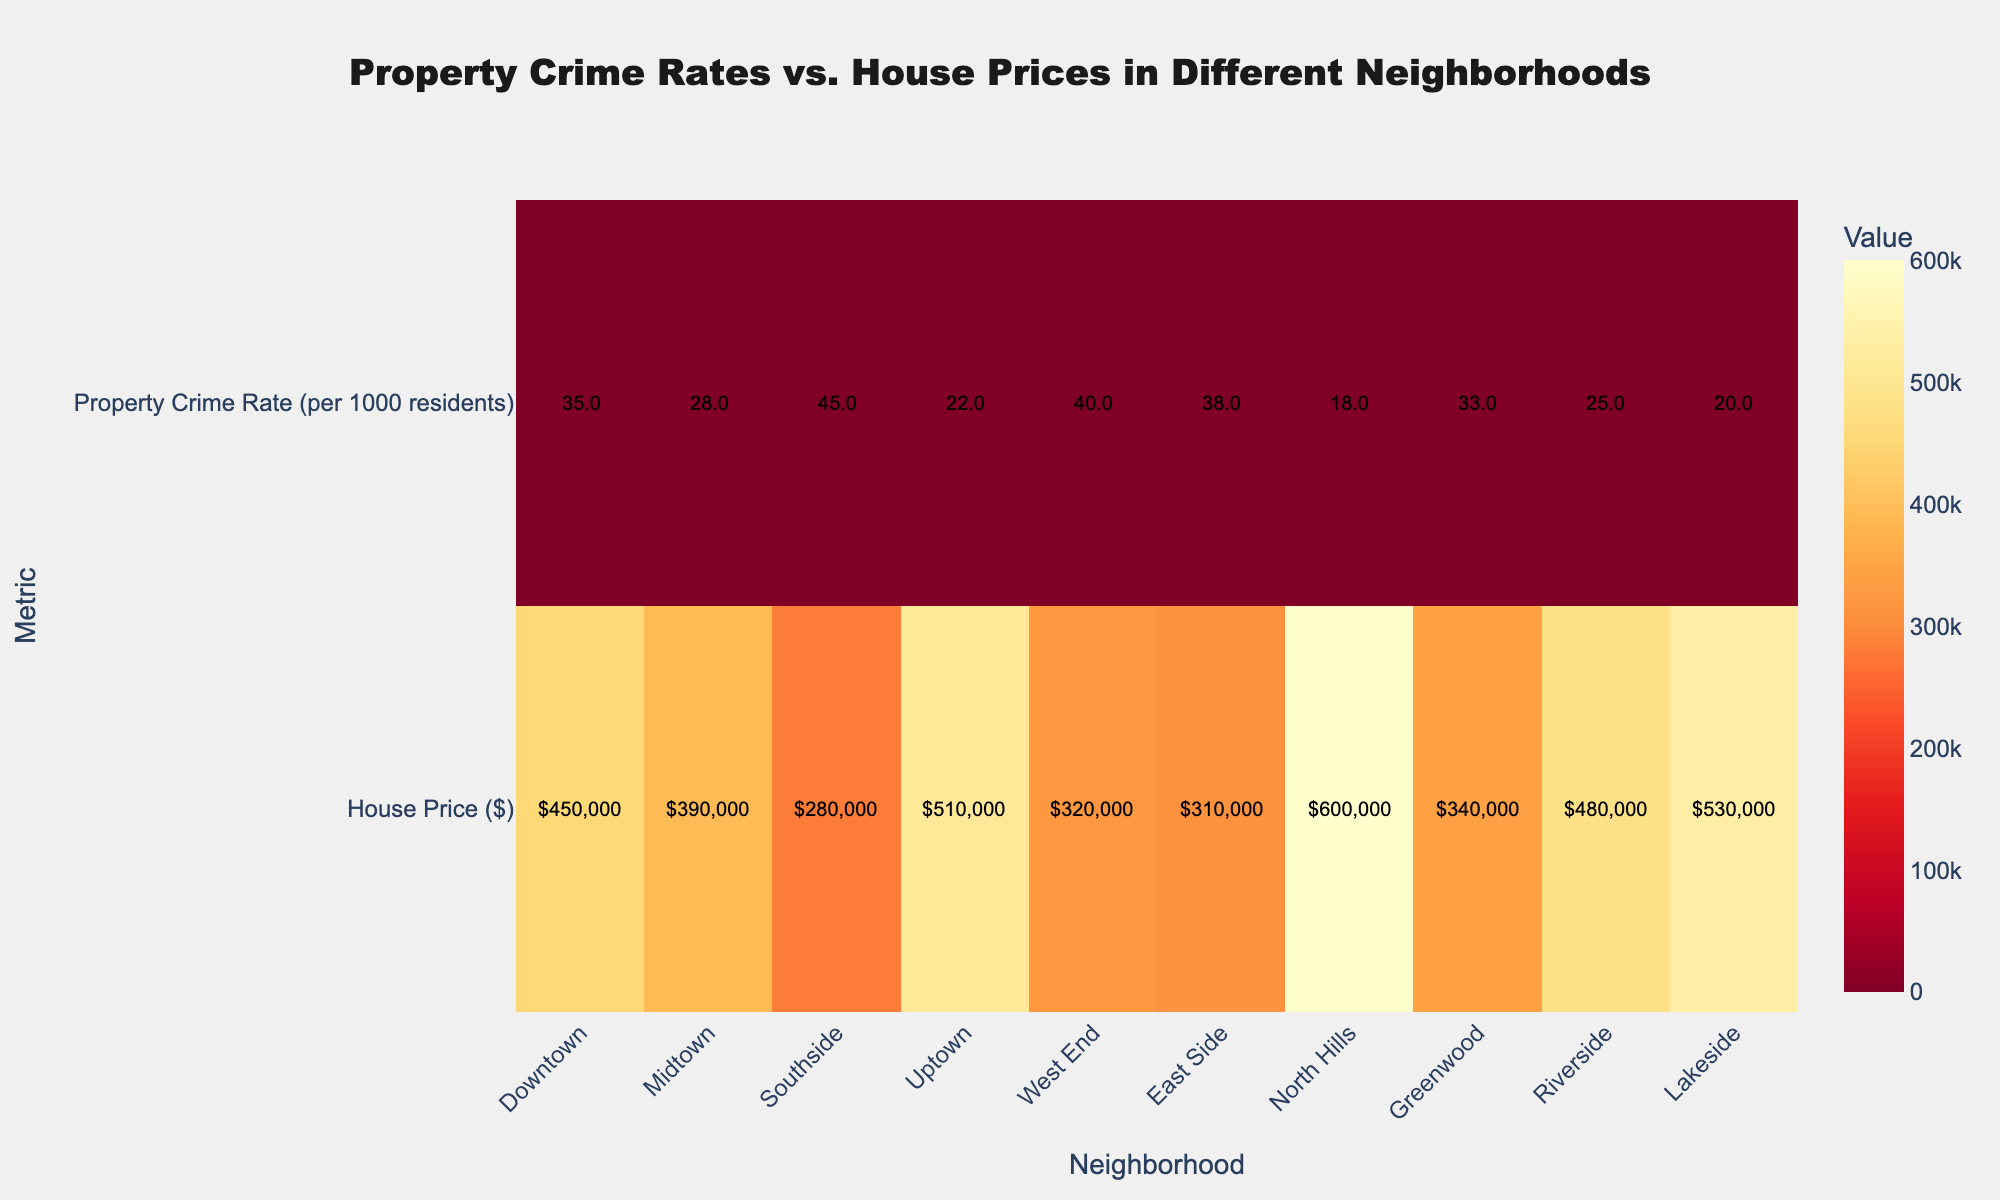What is the title of the figure? The title of the figure is displayed at the top, typically in larger, bold font. It provides a summary of what the figure represents.
Answer: Property Crime Rates vs. House Prices in Different Neighborhoods Which neighborhood has the highest house price? The y-axis shows the metric "House Price ($)" and the corresponding values for each neighborhood on the x-axis. The value $600,000 is visibly the highest on the heatmap.
Answer: North Hills How does the property crime rate in Downtown compare to that in Uptown? By looking at the "Property Crime Rate (per 1000 residents)" for both neighborhoods, Downtown has a higher crime rate of 35 compared to Uptown which has a rate of 22.
Answer: Downtown has a higher crime rate What is the average house price of the neighborhoods displayed? Sum the house prices of all neighborhoods (${450,000 + 390,000 + 280,000 + 510,000 + 320,000 + 310,000 + 600,000 + 340,000 + 480,000 + 530,000}) and divide by the number of neighborhoods (10).
Answer: $421,000 Which neighborhood has the lowest property crime rate? Look at the "Property Crime Rate (per 1000 residents)" values for each neighborhood. The lowest value is 18.
Answer: North Hills What is the difference in house prices between Riverside and Lakeside? Locate the house prices for both neighborhoods; Riverside is $480,000 and Lakeside is $530,000. The difference is $530,000 - $480,000.
Answer: $50,000 Which neighborhood has the highest property crime rate? By observing the values in the "Property Crime Rate (per 1000 residents)" row, the highest value is 45.
Answer: Southside Is the property crime rate in East Side higher or lower than in West End? By comparing the values, East Side has a crime rate of 38, while West End has a rate of 40.
Answer: Lower How many neighborhoods have a property crime rate higher than 30? Count the neighborhoods where the property crime rate exceeds 30: Downtown, Midtown, Southside, West End, East Side, Greenwood.
Answer: 6 neighborhoods What is the average property crime rate across all neighborhoods? Sum the property crime rates for all neighborhoods (35 + 28 + 45 + 22 + 40 + 38 + 18 + 33 + 25 + 20) and divide by the number of neighborhoods (10).
Answer: 30.4 per 1000 residents 